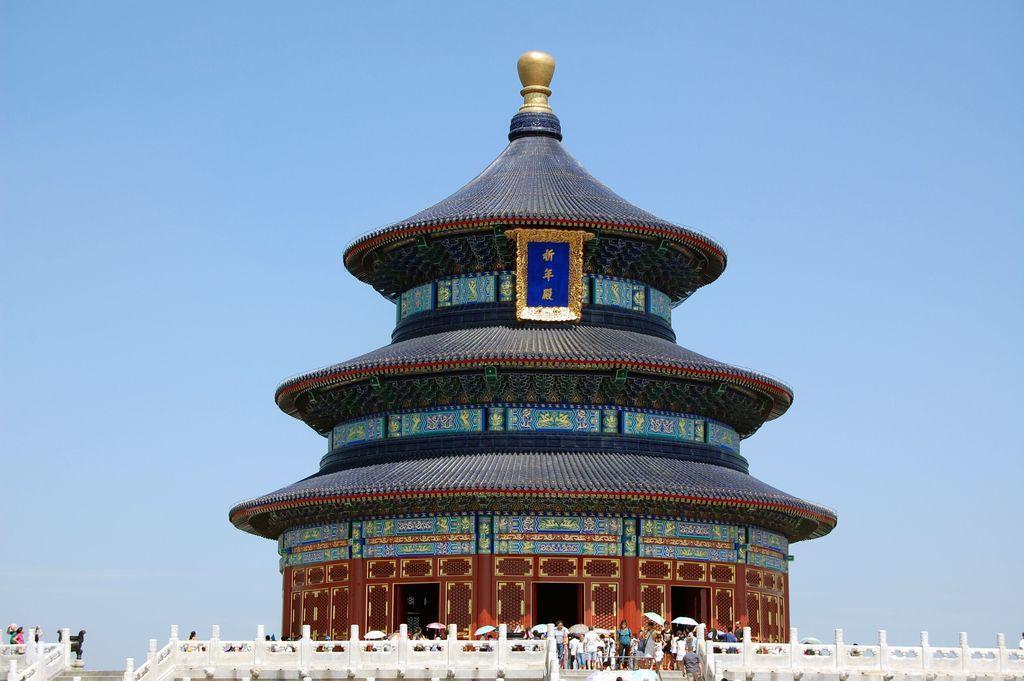Please provide a concise description of this image. As we can see in the image there is a building, stairs, fence, few people here and there, umbrellas and sky. 